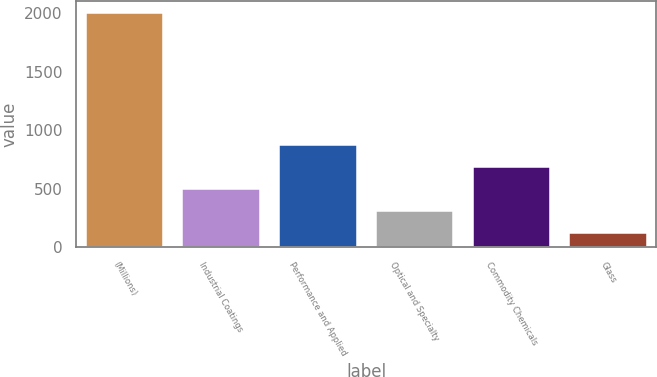<chart> <loc_0><loc_0><loc_500><loc_500><bar_chart><fcel>(Millions)<fcel>Industrial Coatings<fcel>Performance and Applied<fcel>Optical and Specialty<fcel>Commodity Chemicals<fcel>Glass<nl><fcel>2005<fcel>499.4<fcel>875.8<fcel>311.2<fcel>687.6<fcel>123<nl></chart> 